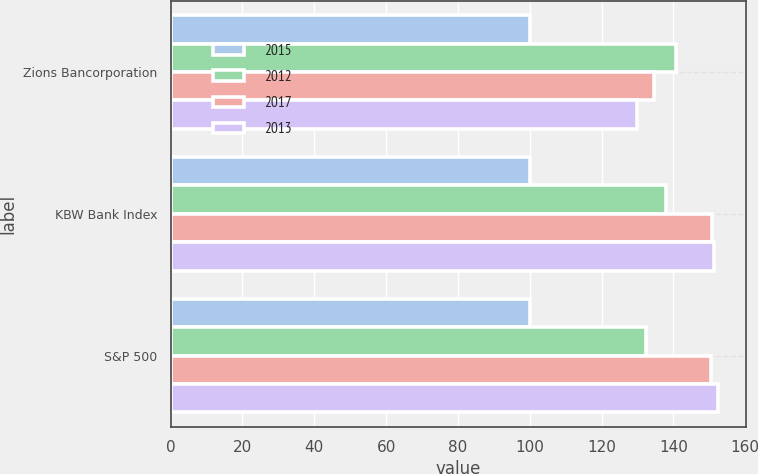Convert chart to OTSL. <chart><loc_0><loc_0><loc_500><loc_500><stacked_bar_chart><ecel><fcel>Zions Bancorporation<fcel>KBW Bank Index<fcel>S&P 500<nl><fcel>2015<fcel>100<fcel>100<fcel>100<nl><fcel>2012<fcel>140.6<fcel>137.8<fcel>132.4<nl><fcel>2017<fcel>134.6<fcel>150.7<fcel>150.5<nl><fcel>2013<fcel>129.8<fcel>151.4<fcel>152.5<nl></chart> 